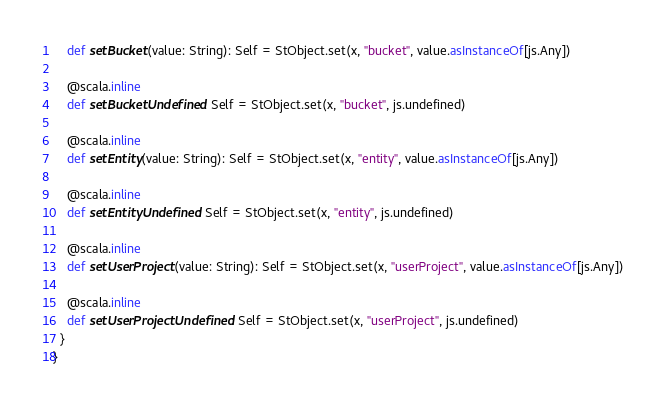Convert code to text. <code><loc_0><loc_0><loc_500><loc_500><_Scala_>    def setBucket(value: String): Self = StObject.set(x, "bucket", value.asInstanceOf[js.Any])
    
    @scala.inline
    def setBucketUndefined: Self = StObject.set(x, "bucket", js.undefined)
    
    @scala.inline
    def setEntity(value: String): Self = StObject.set(x, "entity", value.asInstanceOf[js.Any])
    
    @scala.inline
    def setEntityUndefined: Self = StObject.set(x, "entity", js.undefined)
    
    @scala.inline
    def setUserProject(value: String): Self = StObject.set(x, "userProject", value.asInstanceOf[js.Any])
    
    @scala.inline
    def setUserProjectUndefined: Self = StObject.set(x, "userProject", js.undefined)
  }
}
</code> 